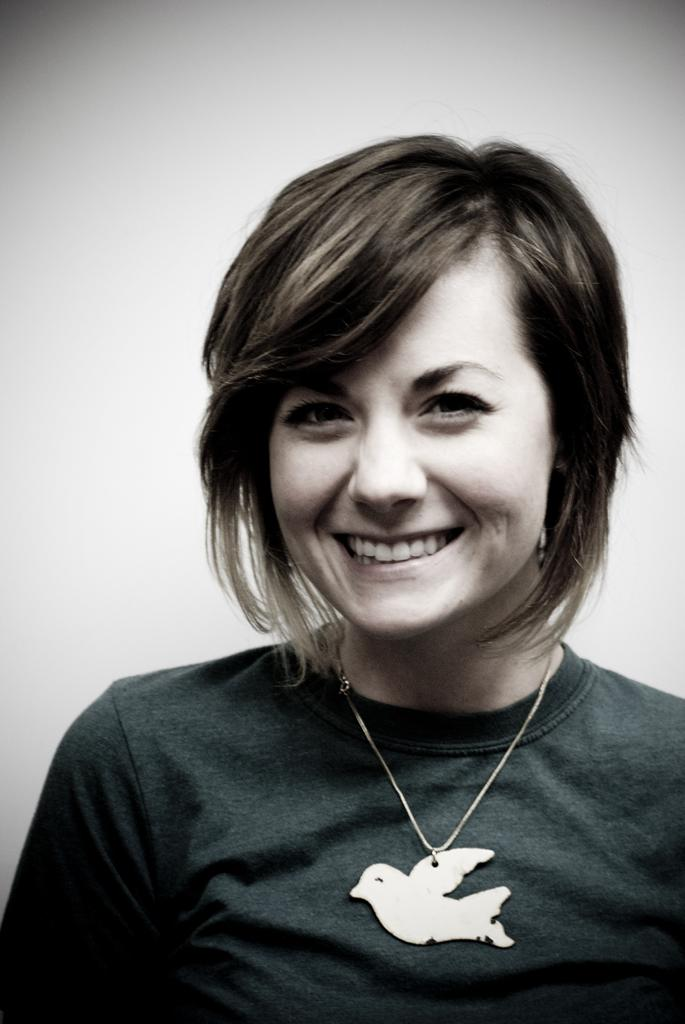Who is present in the image? There is a woman in the image. What is the woman wearing in the image? The woman is wearing a locket in the image. What can be seen in the background of the image? There is a wall in the background of the image. Are there any volcanoes visible in the image? No, there are no volcanoes present in the image. Can you see any bears in the image? No, there are no bears present in the image. 